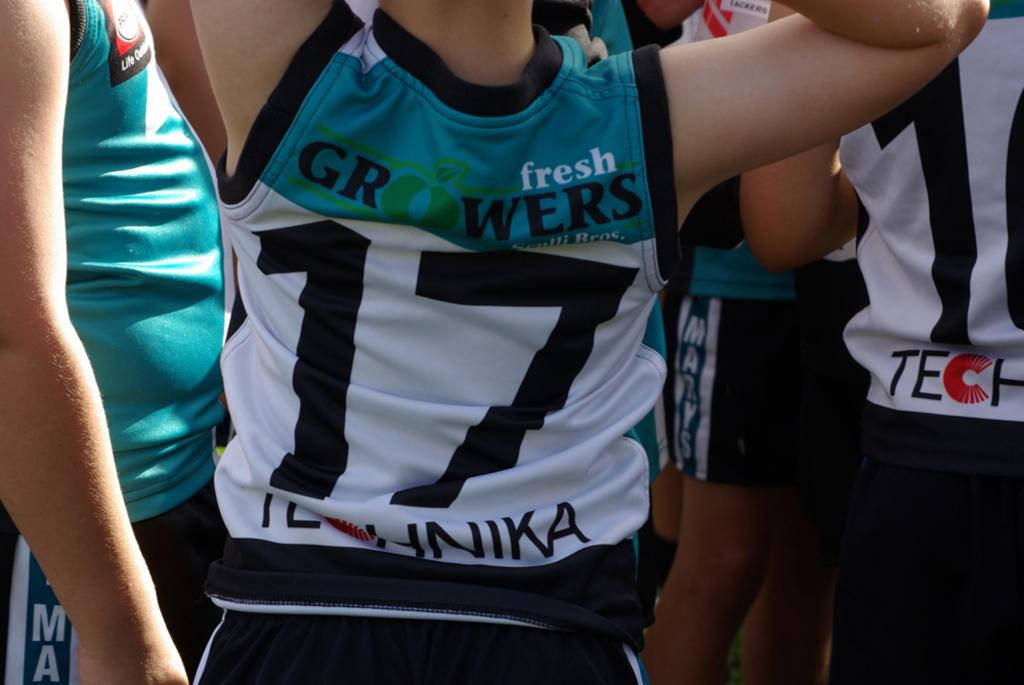<image>
Write a terse but informative summary of the picture. back view of someone wearing blue, white and black fresh growers #17 jersey 